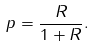<formula> <loc_0><loc_0><loc_500><loc_500>p = \frac { R } { 1 + R } .</formula> 